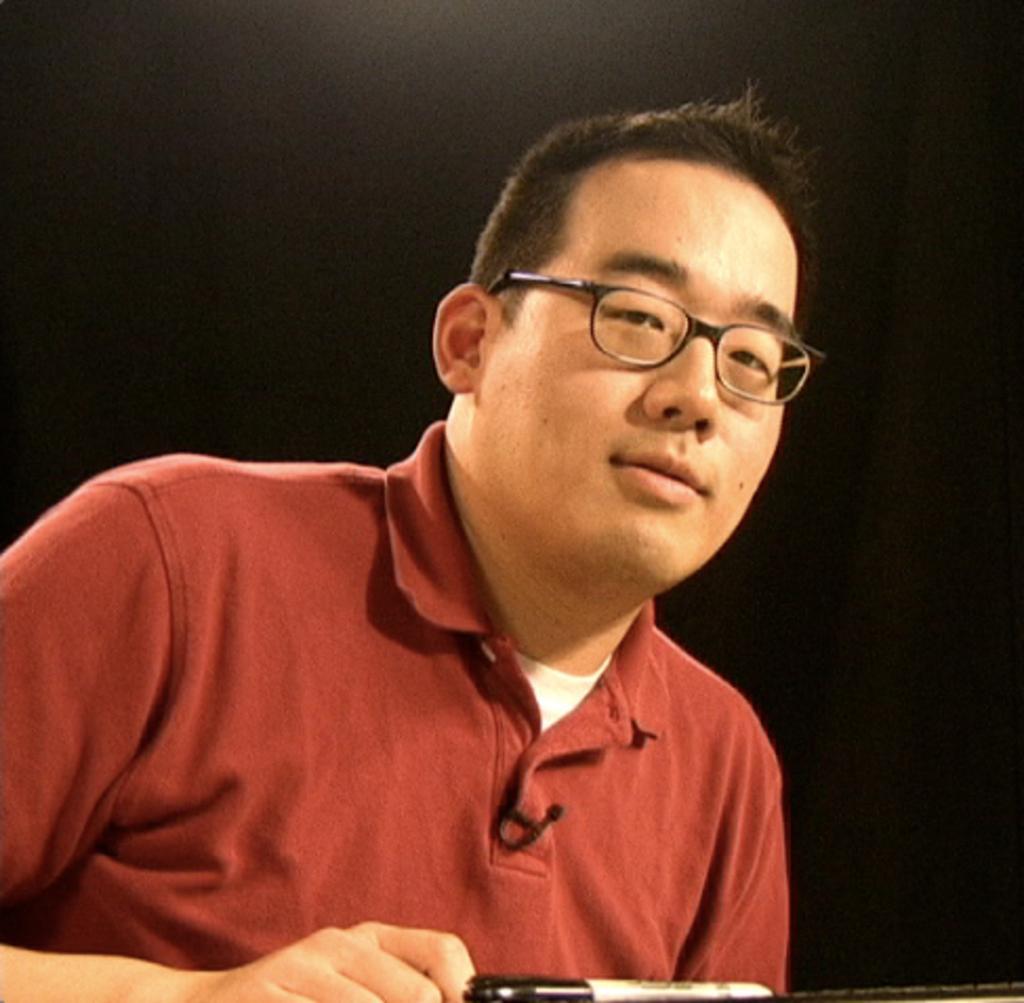Describe this image in one or two sentences. In this picture we can see a man with a red shirt. In Front of him there is a marker with cap. He is wearing a spectacles. 